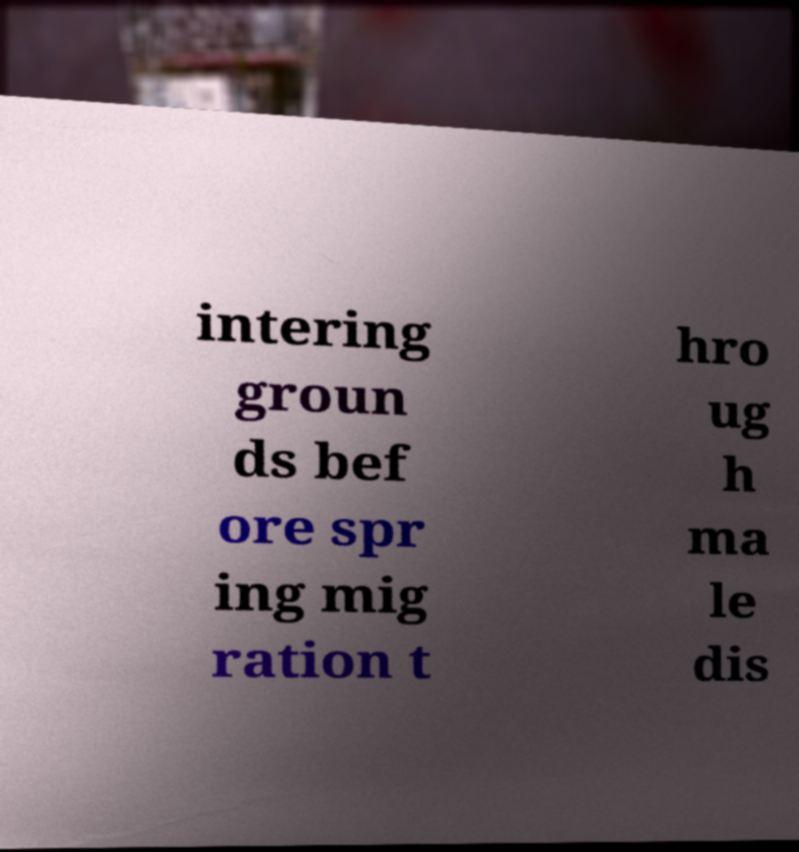Could you extract and type out the text from this image? intering groun ds bef ore spr ing mig ration t hro ug h ma le dis 